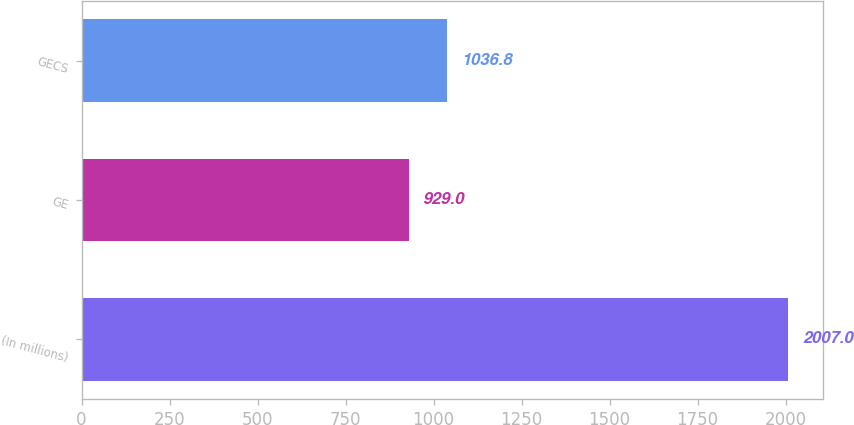Convert chart to OTSL. <chart><loc_0><loc_0><loc_500><loc_500><bar_chart><fcel>(In millions)<fcel>GE<fcel>GECS<nl><fcel>2007<fcel>929<fcel>1036.8<nl></chart> 